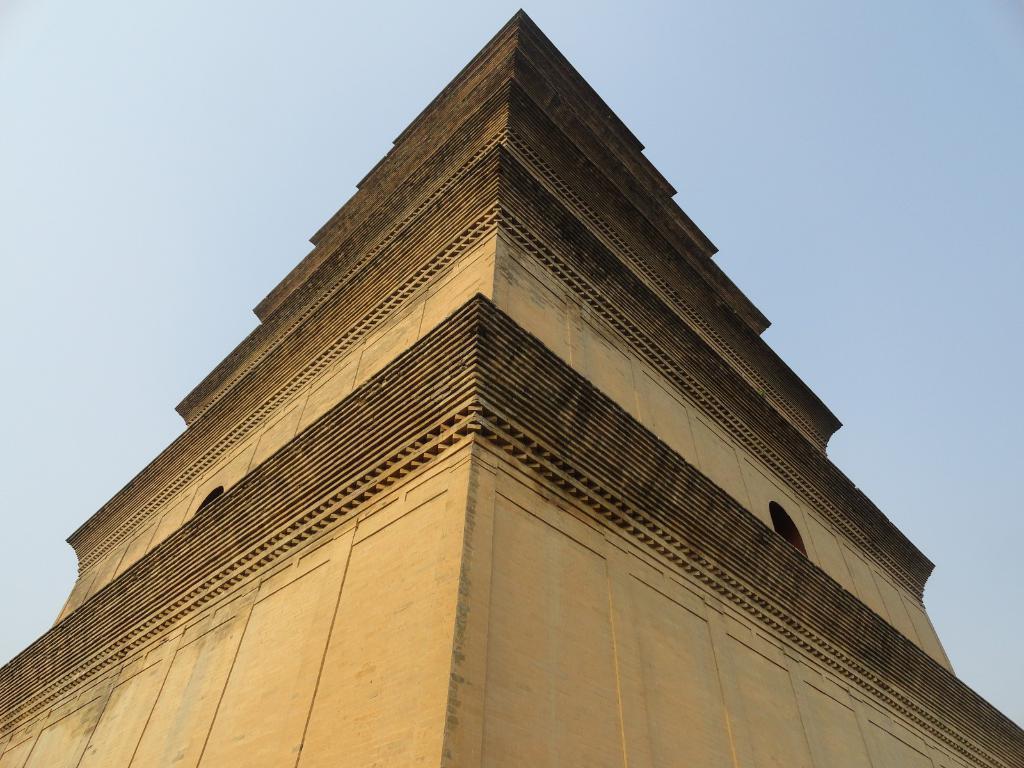How would you summarize this image in a sentence or two? In this image I can see a building which is in cream and black color. The sky is in white and blue color. 